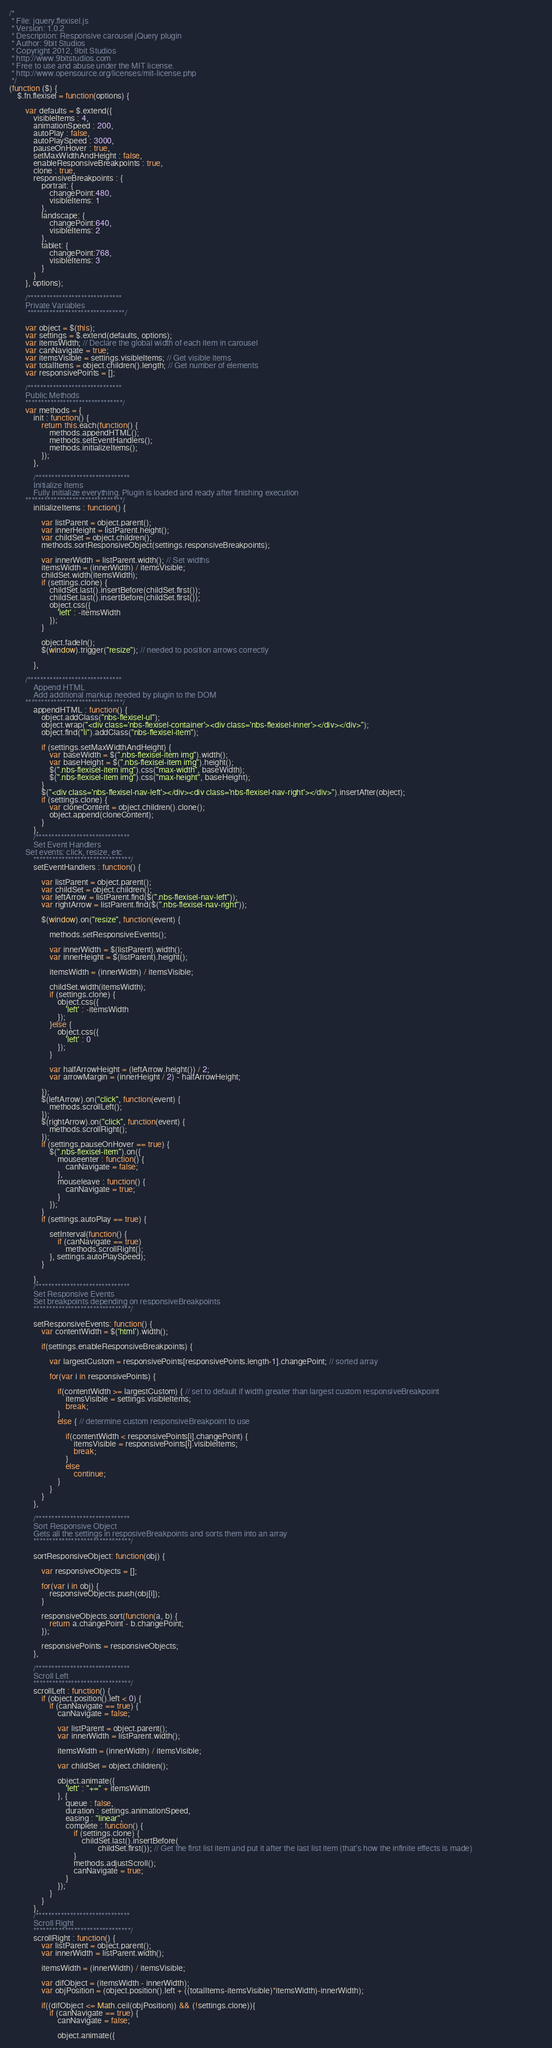<code> <loc_0><loc_0><loc_500><loc_500><_JavaScript_>/*
 * File: jquery.flexisel.js
 * Version: 1.0.2
 * Description: Responsive carousel jQuery plugin
 * Author: 9bit Studios
 * Copyright 2012, 9bit Studios
 * http://www.9bitstudios.com
 * Free to use and abuse under the MIT license.
 * http://www.opensource.org/licenses/mit-license.php
 */
(function ($) {
    $.fn.flexisel = function(options) {
	
        var defaults = $.extend({
            visibleItems : 4,
            animationSpeed : 200,
            autoPlay : false,
            autoPlaySpeed : 3000,
            pauseOnHover : true,
            setMaxWidthAndHeight : false,
            enableResponsiveBreakpoints : true,
            clone : true,
            responsiveBreakpoints : {
                portrait: { 
                    changePoint:480,
                    visibleItems: 1
                }, 
                landscape: { 
                    changePoint:640,
                    visibleItems: 2
                },
                tablet: { 
                    changePoint:768,
                    visibleItems: 3
                }
            }
        }, options);
        
        /******************************
        Private Variables
         *******************************/
         
        var object = $(this);
        var settings = $.extend(defaults, options);
        var itemsWidth; // Declare the global width of each item in carousel
        var canNavigate = true;
        var itemsVisible = settings.visibleItems; // Get visible items
        var totalItems = object.children().length; // Get number of elements
        var responsivePoints = [];
        
        /******************************
        Public Methods
        *******************************/
        var methods = {
            init : function() {
                return this.each(function() {
                    methods.appendHTML();
                    methods.setEventHandlers();
                    methods.initializeItems();
                });
            },
		    
            /******************************
            Initialize Items
            Fully initialize everything. Plugin is loaded and ready after finishing execution
	    *******************************/
            initializeItems : function() {

                var listParent = object.parent();
                var innerHeight = listParent.height();
                var childSet = object.children();
                methods.sortResponsiveObject(settings.responsiveBreakpoints);
                
                var innerWidth = listParent.width(); // Set widths
                itemsWidth = (innerWidth) / itemsVisible;
                childSet.width(itemsWidth);        
                if (settings.clone) {
                    childSet.last().insertBefore(childSet.first());
                    childSet.last().insertBefore(childSet.first());
                    object.css({
                        'left' : -itemsWidth
                    });
                }

                object.fadeIn();
                $(window).trigger("resize"); // needed to position arrows correctly

            },
            
	    /******************************
            Append HTML
            Add additional markup needed by plugin to the DOM
	    *******************************/
            appendHTML : function() {
                object.addClass("nbs-flexisel-ul");
                object.wrap("<div class='nbs-flexisel-container'><div class='nbs-flexisel-inner'></div></div>");
                object.find("li").addClass("nbs-flexisel-item");

                if (settings.setMaxWidthAndHeight) {
                    var baseWidth = $(".nbs-flexisel-item img").width();
                    var baseHeight = $(".nbs-flexisel-item img").height();
                    $(".nbs-flexisel-item img").css("max-width", baseWidth);
                    $(".nbs-flexisel-item img").css("max-height", baseHeight);
                }
                $("<div class='nbs-flexisel-nav-left'></div><div class='nbs-flexisel-nav-right'></div>").insertAfter(object);
                if (settings.clone) {
                    var cloneContent = object.children().clone();
                    object.append(cloneContent);
                }
            },
            /******************************
            Set Event Handlers
	    Set events: click, resize, etc
            *******************************/
            setEventHandlers : function() {

                var listParent = object.parent();
                var childSet = object.children();
                var leftArrow = listParent.find($(".nbs-flexisel-nav-left"));
                var rightArrow = listParent.find($(".nbs-flexisel-nav-right"));

                $(window).on("resize", function(event) {

                    methods.setResponsiveEvents();

                    var innerWidth = $(listParent).width();
                    var innerHeight = $(listParent).height();

                    itemsWidth = (innerWidth) / itemsVisible;

                    childSet.width(itemsWidth);
                    if (settings.clone) {
                        object.css({
                            'left' : -itemsWidth                            
                        });
                    }else {
                        object.css({
                            'left' : 0
                        });
                    }

                    var halfArrowHeight = (leftArrow.height()) / 2;
                    var arrowMargin = (innerHeight / 2) - halfArrowHeight;

                });
                $(leftArrow).on("click", function(event) {
                    methods.scrollLeft();
                });
                $(rightArrow).on("click", function(event) {
                    methods.scrollRight();
                });
                if (settings.pauseOnHover == true) {
                    $(".nbs-flexisel-item").on({
                        mouseenter : function() {
                            canNavigate = false;
                        },
                        mouseleave : function() {
                            canNavigate = true;
                        }
                    });
                }
                if (settings.autoPlay == true) {

                    setInterval(function() {
                        if (canNavigate == true)
                            methods.scrollRight();
                    }, settings.autoPlaySpeed);
                }

            },
            /******************************
            Set Responsive Events
            Set breakpoints depending on responsiveBreakpoints
            *******************************/            
            
            setResponsiveEvents: function() {
                var contentWidth = $('html').width();
                
                if(settings.enableResponsiveBreakpoints) {
                    
                    var largestCustom = responsivePoints[responsivePoints.length-1].changePoint; // sorted array 
                    
                    for(var i in responsivePoints) {
                        
                        if(contentWidth >= largestCustom) { // set to default if width greater than largest custom responsiveBreakpoint 
                            itemsVisible = settings.visibleItems;
                            break;
                        }
                        else { // determine custom responsiveBreakpoint to use
                        
                            if(contentWidth < responsivePoints[i].changePoint) {
                                itemsVisible = responsivePoints[i].visibleItems;
                                break;
                            }
                            else
                                continue;
                        }
                    }
                }
            },

            /******************************
            Sort Responsive Object
            Gets all the settings in resposiveBreakpoints and sorts them into an array
            *******************************/            
            
            sortResponsiveObject: function(obj) {
                
                var responsiveObjects = [];
                
                for(var i in obj) {
                    responsiveObjects.push(obj[i]);
                }
                
                responsiveObjects.sort(function(a, b) {
                    return a.changePoint - b.changePoint;
                });
            
                responsivePoints = responsiveObjects;
            },
            
            /******************************
            Scroll Left
            *******************************/
            scrollLeft : function() {
                if (object.position().left < 0) {
                    if (canNavigate == true) {
                        canNavigate = false;

                        var listParent = object.parent();
                        var innerWidth = listParent.width();

                        itemsWidth = (innerWidth) / itemsVisible;

                        var childSet = object.children();

                        object.animate({
                            'left' : "+=" + itemsWidth
                        }, {
                            queue : false,
                            duration : settings.animationSpeed,
                            easing : "linear",
                            complete : function() {
                                if (settings.clone) {
                                    childSet.last().insertBefore(
                                            childSet.first()); // Get the first list item and put it after the last list item (that's how the infinite effects is made)                                   
                                }
                                methods.adjustScroll();
                                canNavigate = true;
                            }
                        });
                    }
                }
            },
            /******************************
            Scroll Right
            *******************************/            
            scrollRight : function() {
                var listParent = object.parent();
                var innerWidth = listParent.width();

                itemsWidth = (innerWidth) / itemsVisible;

                var difObject = (itemsWidth - innerWidth);
                var objPosition = (object.position().left + ((totalItems-itemsVisible)*itemsWidth)-innerWidth);    
                
                if((difObject <= Math.ceil(objPosition)) && (!settings.clone)){
                    if (canNavigate == true) {
                        canNavigate = false;                    
    
                        object.animate({</code> 